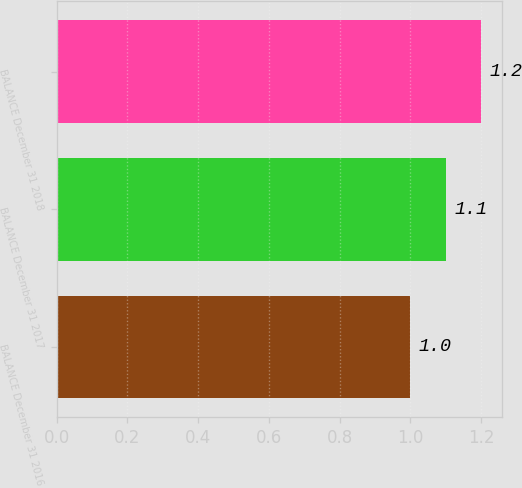<chart> <loc_0><loc_0><loc_500><loc_500><bar_chart><fcel>BALANCE December 31 2016<fcel>BALANCE December 31 2017<fcel>BALANCE December 31 2018<nl><fcel>1<fcel>1.1<fcel>1.2<nl></chart> 